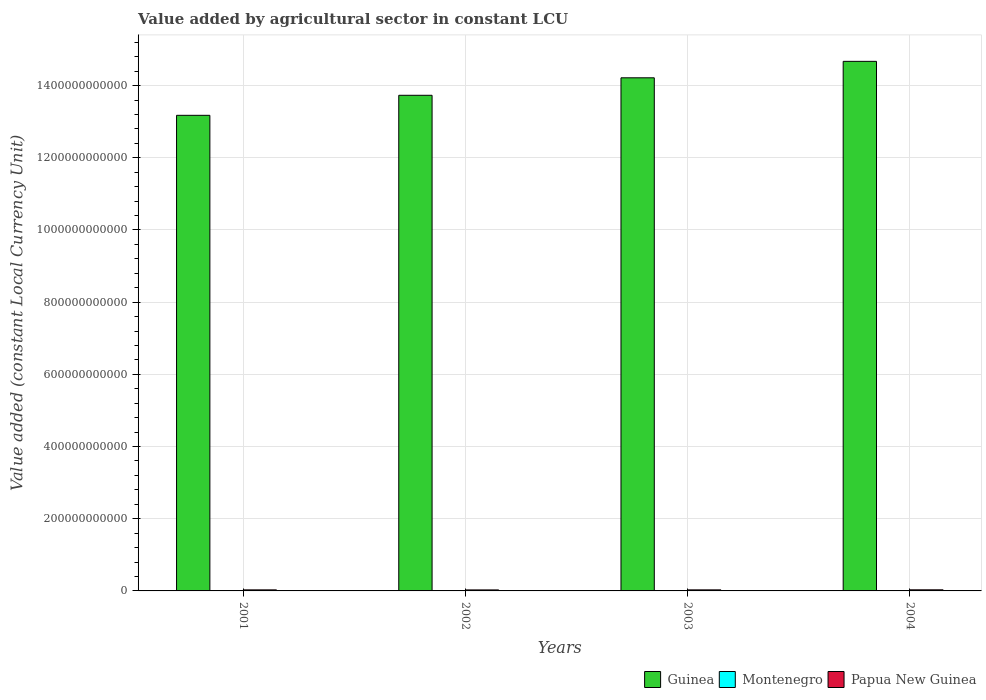How many different coloured bars are there?
Provide a short and direct response. 3. How many groups of bars are there?
Make the answer very short. 4. Are the number of bars on each tick of the X-axis equal?
Give a very brief answer. Yes. How many bars are there on the 4th tick from the left?
Your answer should be compact. 3. What is the label of the 4th group of bars from the left?
Give a very brief answer. 2004. In how many cases, is the number of bars for a given year not equal to the number of legend labels?
Your answer should be very brief. 0. What is the value added by agricultural sector in Guinea in 2002?
Ensure brevity in your answer.  1.37e+12. Across all years, what is the maximum value added by agricultural sector in Papua New Guinea?
Keep it short and to the point. 3.06e+09. Across all years, what is the minimum value added by agricultural sector in Papua New Guinea?
Make the answer very short. 2.79e+09. In which year was the value added by agricultural sector in Papua New Guinea maximum?
Provide a succinct answer. 2004. In which year was the value added by agricultural sector in Guinea minimum?
Provide a succinct answer. 2001. What is the total value added by agricultural sector in Montenegro in the graph?
Provide a succinct answer. 4.09e+08. What is the difference between the value added by agricultural sector in Guinea in 2002 and that in 2004?
Your response must be concise. -9.40e+1. What is the difference between the value added by agricultural sector in Montenegro in 2003 and the value added by agricultural sector in Guinea in 2004?
Ensure brevity in your answer.  -1.47e+12. What is the average value added by agricultural sector in Papua New Guinea per year?
Provide a short and direct response. 2.92e+09. In the year 2002, what is the difference between the value added by agricultural sector in Montenegro and value added by agricultural sector in Guinea?
Provide a short and direct response. -1.37e+12. What is the ratio of the value added by agricultural sector in Guinea in 2001 to that in 2003?
Offer a terse response. 0.93. Is the value added by agricultural sector in Papua New Guinea in 2001 less than that in 2003?
Offer a very short reply. Yes. Is the difference between the value added by agricultural sector in Montenegro in 2002 and 2003 greater than the difference between the value added by agricultural sector in Guinea in 2002 and 2003?
Your answer should be very brief. Yes. What is the difference between the highest and the second highest value added by agricultural sector in Guinea?
Offer a very short reply. 4.56e+1. What is the difference between the highest and the lowest value added by agricultural sector in Montenegro?
Offer a terse response. 1.78e+07. Is the sum of the value added by agricultural sector in Montenegro in 2001 and 2003 greater than the maximum value added by agricultural sector in Papua New Guinea across all years?
Offer a terse response. No. What does the 1st bar from the left in 2002 represents?
Give a very brief answer. Guinea. What does the 3rd bar from the right in 2001 represents?
Provide a succinct answer. Guinea. Is it the case that in every year, the sum of the value added by agricultural sector in Papua New Guinea and value added by agricultural sector in Montenegro is greater than the value added by agricultural sector in Guinea?
Make the answer very short. No. What is the difference between two consecutive major ticks on the Y-axis?
Make the answer very short. 2.00e+11. Where does the legend appear in the graph?
Give a very brief answer. Bottom right. How are the legend labels stacked?
Offer a very short reply. Horizontal. What is the title of the graph?
Provide a succinct answer. Value added by agricultural sector in constant LCU. Does "Chad" appear as one of the legend labels in the graph?
Your answer should be very brief. No. What is the label or title of the X-axis?
Your answer should be very brief. Years. What is the label or title of the Y-axis?
Your answer should be very brief. Value added (constant Local Currency Unit). What is the Value added (constant Local Currency Unit) in Guinea in 2001?
Provide a short and direct response. 1.32e+12. What is the Value added (constant Local Currency Unit) in Montenegro in 2001?
Give a very brief answer. 1.14e+08. What is the Value added (constant Local Currency Unit) of Papua New Guinea in 2001?
Keep it short and to the point. 2.91e+09. What is the Value added (constant Local Currency Unit) in Guinea in 2002?
Provide a short and direct response. 1.37e+12. What is the Value added (constant Local Currency Unit) in Montenegro in 2002?
Give a very brief answer. 1.03e+08. What is the Value added (constant Local Currency Unit) in Papua New Guinea in 2002?
Make the answer very short. 2.79e+09. What is the Value added (constant Local Currency Unit) in Guinea in 2003?
Your answer should be compact. 1.42e+12. What is the Value added (constant Local Currency Unit) in Montenegro in 2003?
Offer a terse response. 9.61e+07. What is the Value added (constant Local Currency Unit) of Papua New Guinea in 2003?
Your answer should be very brief. 2.93e+09. What is the Value added (constant Local Currency Unit) in Guinea in 2004?
Make the answer very short. 1.47e+12. What is the Value added (constant Local Currency Unit) in Montenegro in 2004?
Offer a very short reply. 9.60e+07. What is the Value added (constant Local Currency Unit) in Papua New Guinea in 2004?
Offer a terse response. 3.06e+09. Across all years, what is the maximum Value added (constant Local Currency Unit) in Guinea?
Ensure brevity in your answer.  1.47e+12. Across all years, what is the maximum Value added (constant Local Currency Unit) of Montenegro?
Provide a short and direct response. 1.14e+08. Across all years, what is the maximum Value added (constant Local Currency Unit) in Papua New Guinea?
Your response must be concise. 3.06e+09. Across all years, what is the minimum Value added (constant Local Currency Unit) in Guinea?
Provide a succinct answer. 1.32e+12. Across all years, what is the minimum Value added (constant Local Currency Unit) in Montenegro?
Your response must be concise. 9.60e+07. Across all years, what is the minimum Value added (constant Local Currency Unit) in Papua New Guinea?
Your answer should be very brief. 2.79e+09. What is the total Value added (constant Local Currency Unit) in Guinea in the graph?
Make the answer very short. 5.58e+12. What is the total Value added (constant Local Currency Unit) of Montenegro in the graph?
Ensure brevity in your answer.  4.09e+08. What is the total Value added (constant Local Currency Unit) of Papua New Guinea in the graph?
Your response must be concise. 1.17e+1. What is the difference between the Value added (constant Local Currency Unit) of Guinea in 2001 and that in 2002?
Offer a very short reply. -5.55e+1. What is the difference between the Value added (constant Local Currency Unit) in Montenegro in 2001 and that in 2002?
Make the answer very short. 1.10e+07. What is the difference between the Value added (constant Local Currency Unit) in Papua New Guinea in 2001 and that in 2002?
Make the answer very short. 1.20e+08. What is the difference between the Value added (constant Local Currency Unit) in Guinea in 2001 and that in 2003?
Ensure brevity in your answer.  -1.04e+11. What is the difference between the Value added (constant Local Currency Unit) in Montenegro in 2001 and that in 2003?
Offer a terse response. 1.77e+07. What is the difference between the Value added (constant Local Currency Unit) in Papua New Guinea in 2001 and that in 2003?
Offer a very short reply. -1.83e+07. What is the difference between the Value added (constant Local Currency Unit) of Guinea in 2001 and that in 2004?
Offer a terse response. -1.49e+11. What is the difference between the Value added (constant Local Currency Unit) in Montenegro in 2001 and that in 2004?
Offer a terse response. 1.78e+07. What is the difference between the Value added (constant Local Currency Unit) of Papua New Guinea in 2001 and that in 2004?
Provide a short and direct response. -1.53e+08. What is the difference between the Value added (constant Local Currency Unit) of Guinea in 2002 and that in 2003?
Give a very brief answer. -4.84e+1. What is the difference between the Value added (constant Local Currency Unit) of Montenegro in 2002 and that in 2003?
Ensure brevity in your answer.  6.72e+06. What is the difference between the Value added (constant Local Currency Unit) of Papua New Guinea in 2002 and that in 2003?
Provide a succinct answer. -1.38e+08. What is the difference between the Value added (constant Local Currency Unit) of Guinea in 2002 and that in 2004?
Offer a terse response. -9.40e+1. What is the difference between the Value added (constant Local Currency Unit) in Montenegro in 2002 and that in 2004?
Your answer should be very brief. 6.82e+06. What is the difference between the Value added (constant Local Currency Unit) of Papua New Guinea in 2002 and that in 2004?
Ensure brevity in your answer.  -2.73e+08. What is the difference between the Value added (constant Local Currency Unit) in Guinea in 2003 and that in 2004?
Make the answer very short. -4.56e+1. What is the difference between the Value added (constant Local Currency Unit) in Montenegro in 2003 and that in 2004?
Make the answer very short. 1.03e+05. What is the difference between the Value added (constant Local Currency Unit) of Papua New Guinea in 2003 and that in 2004?
Keep it short and to the point. -1.35e+08. What is the difference between the Value added (constant Local Currency Unit) in Guinea in 2001 and the Value added (constant Local Currency Unit) in Montenegro in 2002?
Give a very brief answer. 1.32e+12. What is the difference between the Value added (constant Local Currency Unit) in Guinea in 2001 and the Value added (constant Local Currency Unit) in Papua New Guinea in 2002?
Your answer should be very brief. 1.31e+12. What is the difference between the Value added (constant Local Currency Unit) in Montenegro in 2001 and the Value added (constant Local Currency Unit) in Papua New Guinea in 2002?
Offer a terse response. -2.67e+09. What is the difference between the Value added (constant Local Currency Unit) in Guinea in 2001 and the Value added (constant Local Currency Unit) in Montenegro in 2003?
Provide a short and direct response. 1.32e+12. What is the difference between the Value added (constant Local Currency Unit) in Guinea in 2001 and the Value added (constant Local Currency Unit) in Papua New Guinea in 2003?
Give a very brief answer. 1.31e+12. What is the difference between the Value added (constant Local Currency Unit) in Montenegro in 2001 and the Value added (constant Local Currency Unit) in Papua New Guinea in 2003?
Your answer should be compact. -2.81e+09. What is the difference between the Value added (constant Local Currency Unit) of Guinea in 2001 and the Value added (constant Local Currency Unit) of Montenegro in 2004?
Make the answer very short. 1.32e+12. What is the difference between the Value added (constant Local Currency Unit) of Guinea in 2001 and the Value added (constant Local Currency Unit) of Papua New Guinea in 2004?
Give a very brief answer. 1.31e+12. What is the difference between the Value added (constant Local Currency Unit) of Montenegro in 2001 and the Value added (constant Local Currency Unit) of Papua New Guinea in 2004?
Your answer should be very brief. -2.95e+09. What is the difference between the Value added (constant Local Currency Unit) in Guinea in 2002 and the Value added (constant Local Currency Unit) in Montenegro in 2003?
Give a very brief answer. 1.37e+12. What is the difference between the Value added (constant Local Currency Unit) in Guinea in 2002 and the Value added (constant Local Currency Unit) in Papua New Guinea in 2003?
Provide a succinct answer. 1.37e+12. What is the difference between the Value added (constant Local Currency Unit) of Montenegro in 2002 and the Value added (constant Local Currency Unit) of Papua New Guinea in 2003?
Provide a succinct answer. -2.82e+09. What is the difference between the Value added (constant Local Currency Unit) of Guinea in 2002 and the Value added (constant Local Currency Unit) of Montenegro in 2004?
Your response must be concise. 1.37e+12. What is the difference between the Value added (constant Local Currency Unit) in Guinea in 2002 and the Value added (constant Local Currency Unit) in Papua New Guinea in 2004?
Provide a succinct answer. 1.37e+12. What is the difference between the Value added (constant Local Currency Unit) of Montenegro in 2002 and the Value added (constant Local Currency Unit) of Papua New Guinea in 2004?
Your answer should be very brief. -2.96e+09. What is the difference between the Value added (constant Local Currency Unit) of Guinea in 2003 and the Value added (constant Local Currency Unit) of Montenegro in 2004?
Provide a succinct answer. 1.42e+12. What is the difference between the Value added (constant Local Currency Unit) in Guinea in 2003 and the Value added (constant Local Currency Unit) in Papua New Guinea in 2004?
Your response must be concise. 1.42e+12. What is the difference between the Value added (constant Local Currency Unit) of Montenegro in 2003 and the Value added (constant Local Currency Unit) of Papua New Guinea in 2004?
Your answer should be very brief. -2.97e+09. What is the average Value added (constant Local Currency Unit) in Guinea per year?
Provide a short and direct response. 1.39e+12. What is the average Value added (constant Local Currency Unit) in Montenegro per year?
Offer a very short reply. 1.02e+08. What is the average Value added (constant Local Currency Unit) of Papua New Guinea per year?
Give a very brief answer. 2.92e+09. In the year 2001, what is the difference between the Value added (constant Local Currency Unit) in Guinea and Value added (constant Local Currency Unit) in Montenegro?
Keep it short and to the point. 1.32e+12. In the year 2001, what is the difference between the Value added (constant Local Currency Unit) in Guinea and Value added (constant Local Currency Unit) in Papua New Guinea?
Your response must be concise. 1.31e+12. In the year 2001, what is the difference between the Value added (constant Local Currency Unit) of Montenegro and Value added (constant Local Currency Unit) of Papua New Guinea?
Give a very brief answer. -2.80e+09. In the year 2002, what is the difference between the Value added (constant Local Currency Unit) of Guinea and Value added (constant Local Currency Unit) of Montenegro?
Provide a short and direct response. 1.37e+12. In the year 2002, what is the difference between the Value added (constant Local Currency Unit) of Guinea and Value added (constant Local Currency Unit) of Papua New Guinea?
Make the answer very short. 1.37e+12. In the year 2002, what is the difference between the Value added (constant Local Currency Unit) of Montenegro and Value added (constant Local Currency Unit) of Papua New Guinea?
Your answer should be compact. -2.69e+09. In the year 2003, what is the difference between the Value added (constant Local Currency Unit) in Guinea and Value added (constant Local Currency Unit) in Montenegro?
Ensure brevity in your answer.  1.42e+12. In the year 2003, what is the difference between the Value added (constant Local Currency Unit) in Guinea and Value added (constant Local Currency Unit) in Papua New Guinea?
Ensure brevity in your answer.  1.42e+12. In the year 2003, what is the difference between the Value added (constant Local Currency Unit) in Montenegro and Value added (constant Local Currency Unit) in Papua New Guinea?
Your answer should be very brief. -2.83e+09. In the year 2004, what is the difference between the Value added (constant Local Currency Unit) of Guinea and Value added (constant Local Currency Unit) of Montenegro?
Provide a short and direct response. 1.47e+12. In the year 2004, what is the difference between the Value added (constant Local Currency Unit) of Guinea and Value added (constant Local Currency Unit) of Papua New Guinea?
Provide a short and direct response. 1.46e+12. In the year 2004, what is the difference between the Value added (constant Local Currency Unit) of Montenegro and Value added (constant Local Currency Unit) of Papua New Guinea?
Keep it short and to the point. -2.97e+09. What is the ratio of the Value added (constant Local Currency Unit) of Guinea in 2001 to that in 2002?
Give a very brief answer. 0.96. What is the ratio of the Value added (constant Local Currency Unit) of Montenegro in 2001 to that in 2002?
Offer a very short reply. 1.11. What is the ratio of the Value added (constant Local Currency Unit) in Papua New Guinea in 2001 to that in 2002?
Keep it short and to the point. 1.04. What is the ratio of the Value added (constant Local Currency Unit) of Guinea in 2001 to that in 2003?
Give a very brief answer. 0.93. What is the ratio of the Value added (constant Local Currency Unit) of Montenegro in 2001 to that in 2003?
Ensure brevity in your answer.  1.18. What is the ratio of the Value added (constant Local Currency Unit) of Guinea in 2001 to that in 2004?
Offer a terse response. 0.9. What is the ratio of the Value added (constant Local Currency Unit) in Montenegro in 2001 to that in 2004?
Provide a short and direct response. 1.19. What is the ratio of the Value added (constant Local Currency Unit) in Papua New Guinea in 2001 to that in 2004?
Offer a terse response. 0.95. What is the ratio of the Value added (constant Local Currency Unit) of Guinea in 2002 to that in 2003?
Ensure brevity in your answer.  0.97. What is the ratio of the Value added (constant Local Currency Unit) of Montenegro in 2002 to that in 2003?
Ensure brevity in your answer.  1.07. What is the ratio of the Value added (constant Local Currency Unit) in Papua New Guinea in 2002 to that in 2003?
Your response must be concise. 0.95. What is the ratio of the Value added (constant Local Currency Unit) in Guinea in 2002 to that in 2004?
Your answer should be very brief. 0.94. What is the ratio of the Value added (constant Local Currency Unit) in Montenegro in 2002 to that in 2004?
Make the answer very short. 1.07. What is the ratio of the Value added (constant Local Currency Unit) of Papua New Guinea in 2002 to that in 2004?
Offer a very short reply. 0.91. What is the ratio of the Value added (constant Local Currency Unit) of Guinea in 2003 to that in 2004?
Give a very brief answer. 0.97. What is the ratio of the Value added (constant Local Currency Unit) of Papua New Guinea in 2003 to that in 2004?
Offer a very short reply. 0.96. What is the difference between the highest and the second highest Value added (constant Local Currency Unit) of Guinea?
Your answer should be very brief. 4.56e+1. What is the difference between the highest and the second highest Value added (constant Local Currency Unit) in Montenegro?
Provide a short and direct response. 1.10e+07. What is the difference between the highest and the second highest Value added (constant Local Currency Unit) of Papua New Guinea?
Your answer should be compact. 1.35e+08. What is the difference between the highest and the lowest Value added (constant Local Currency Unit) of Guinea?
Provide a succinct answer. 1.49e+11. What is the difference between the highest and the lowest Value added (constant Local Currency Unit) of Montenegro?
Make the answer very short. 1.78e+07. What is the difference between the highest and the lowest Value added (constant Local Currency Unit) in Papua New Guinea?
Keep it short and to the point. 2.73e+08. 